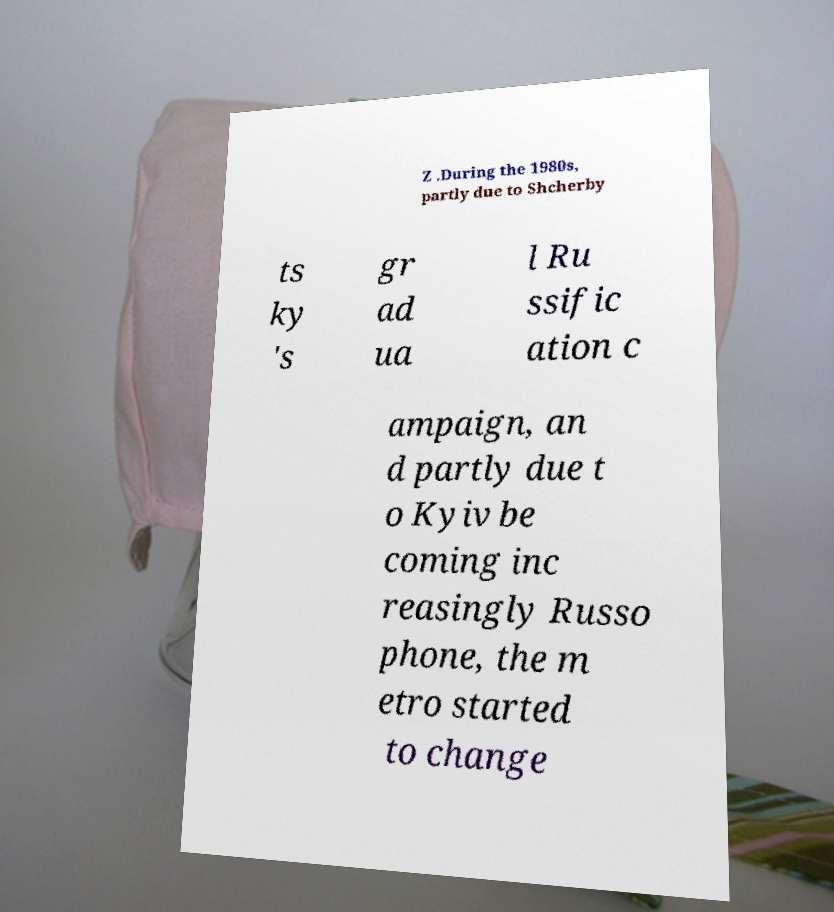There's text embedded in this image that I need extracted. Can you transcribe it verbatim? Z .During the 1980s, partly due to Shcherby ts ky 's gr ad ua l Ru ssific ation c ampaign, an d partly due t o Kyiv be coming inc reasingly Russo phone, the m etro started to change 